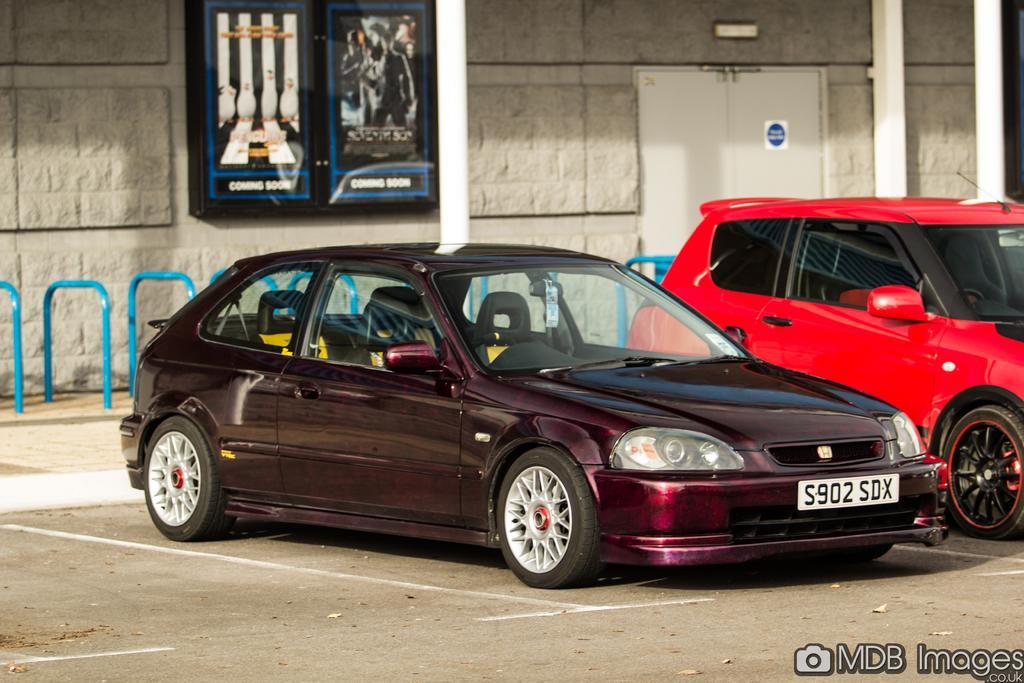In one or two sentences, can you explain what this image depicts? In this image we can see these two cars are parked on the road. In the background, we can see the stone wall and boards fixed to the wall. Here we can see the door and pillars. Here we can see some edited text. 